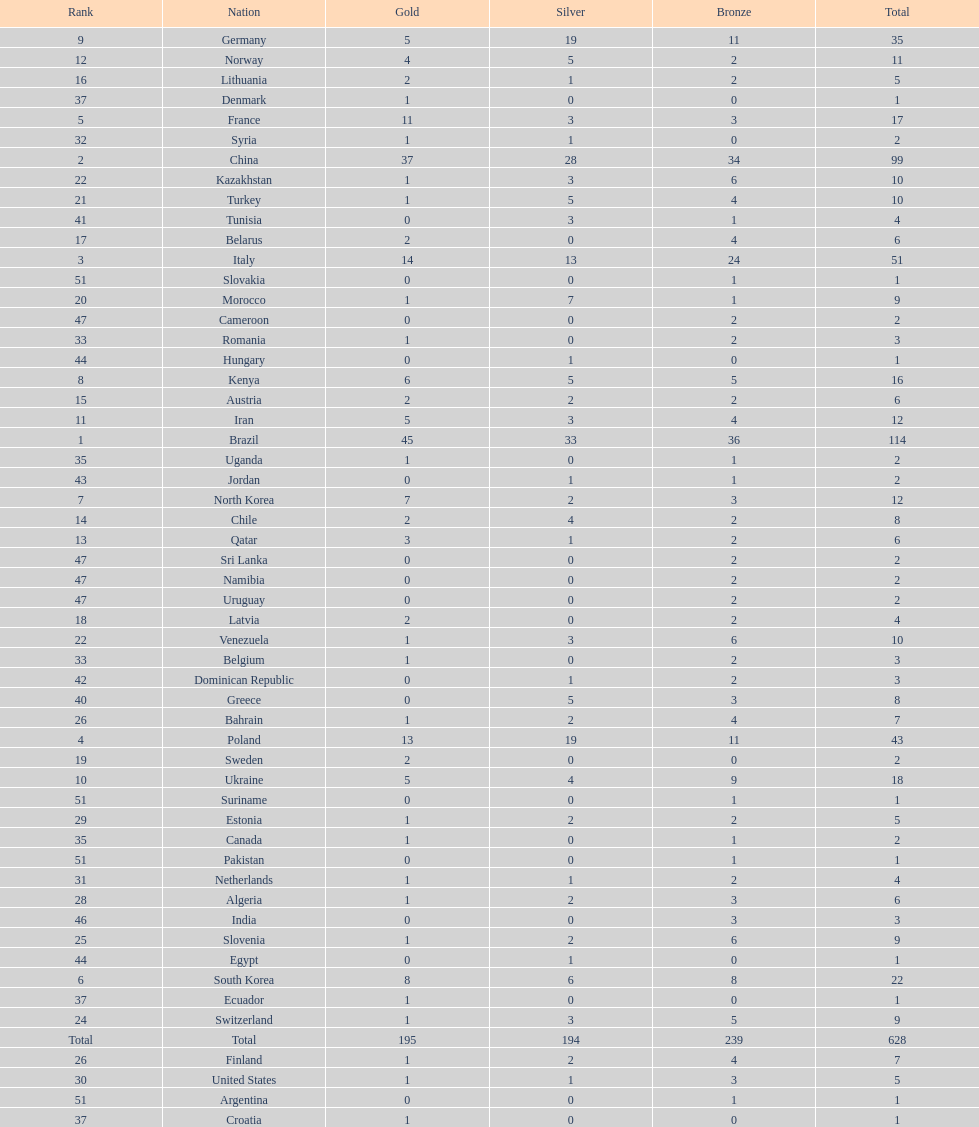Which type of medal does belarus not have? Silver. 